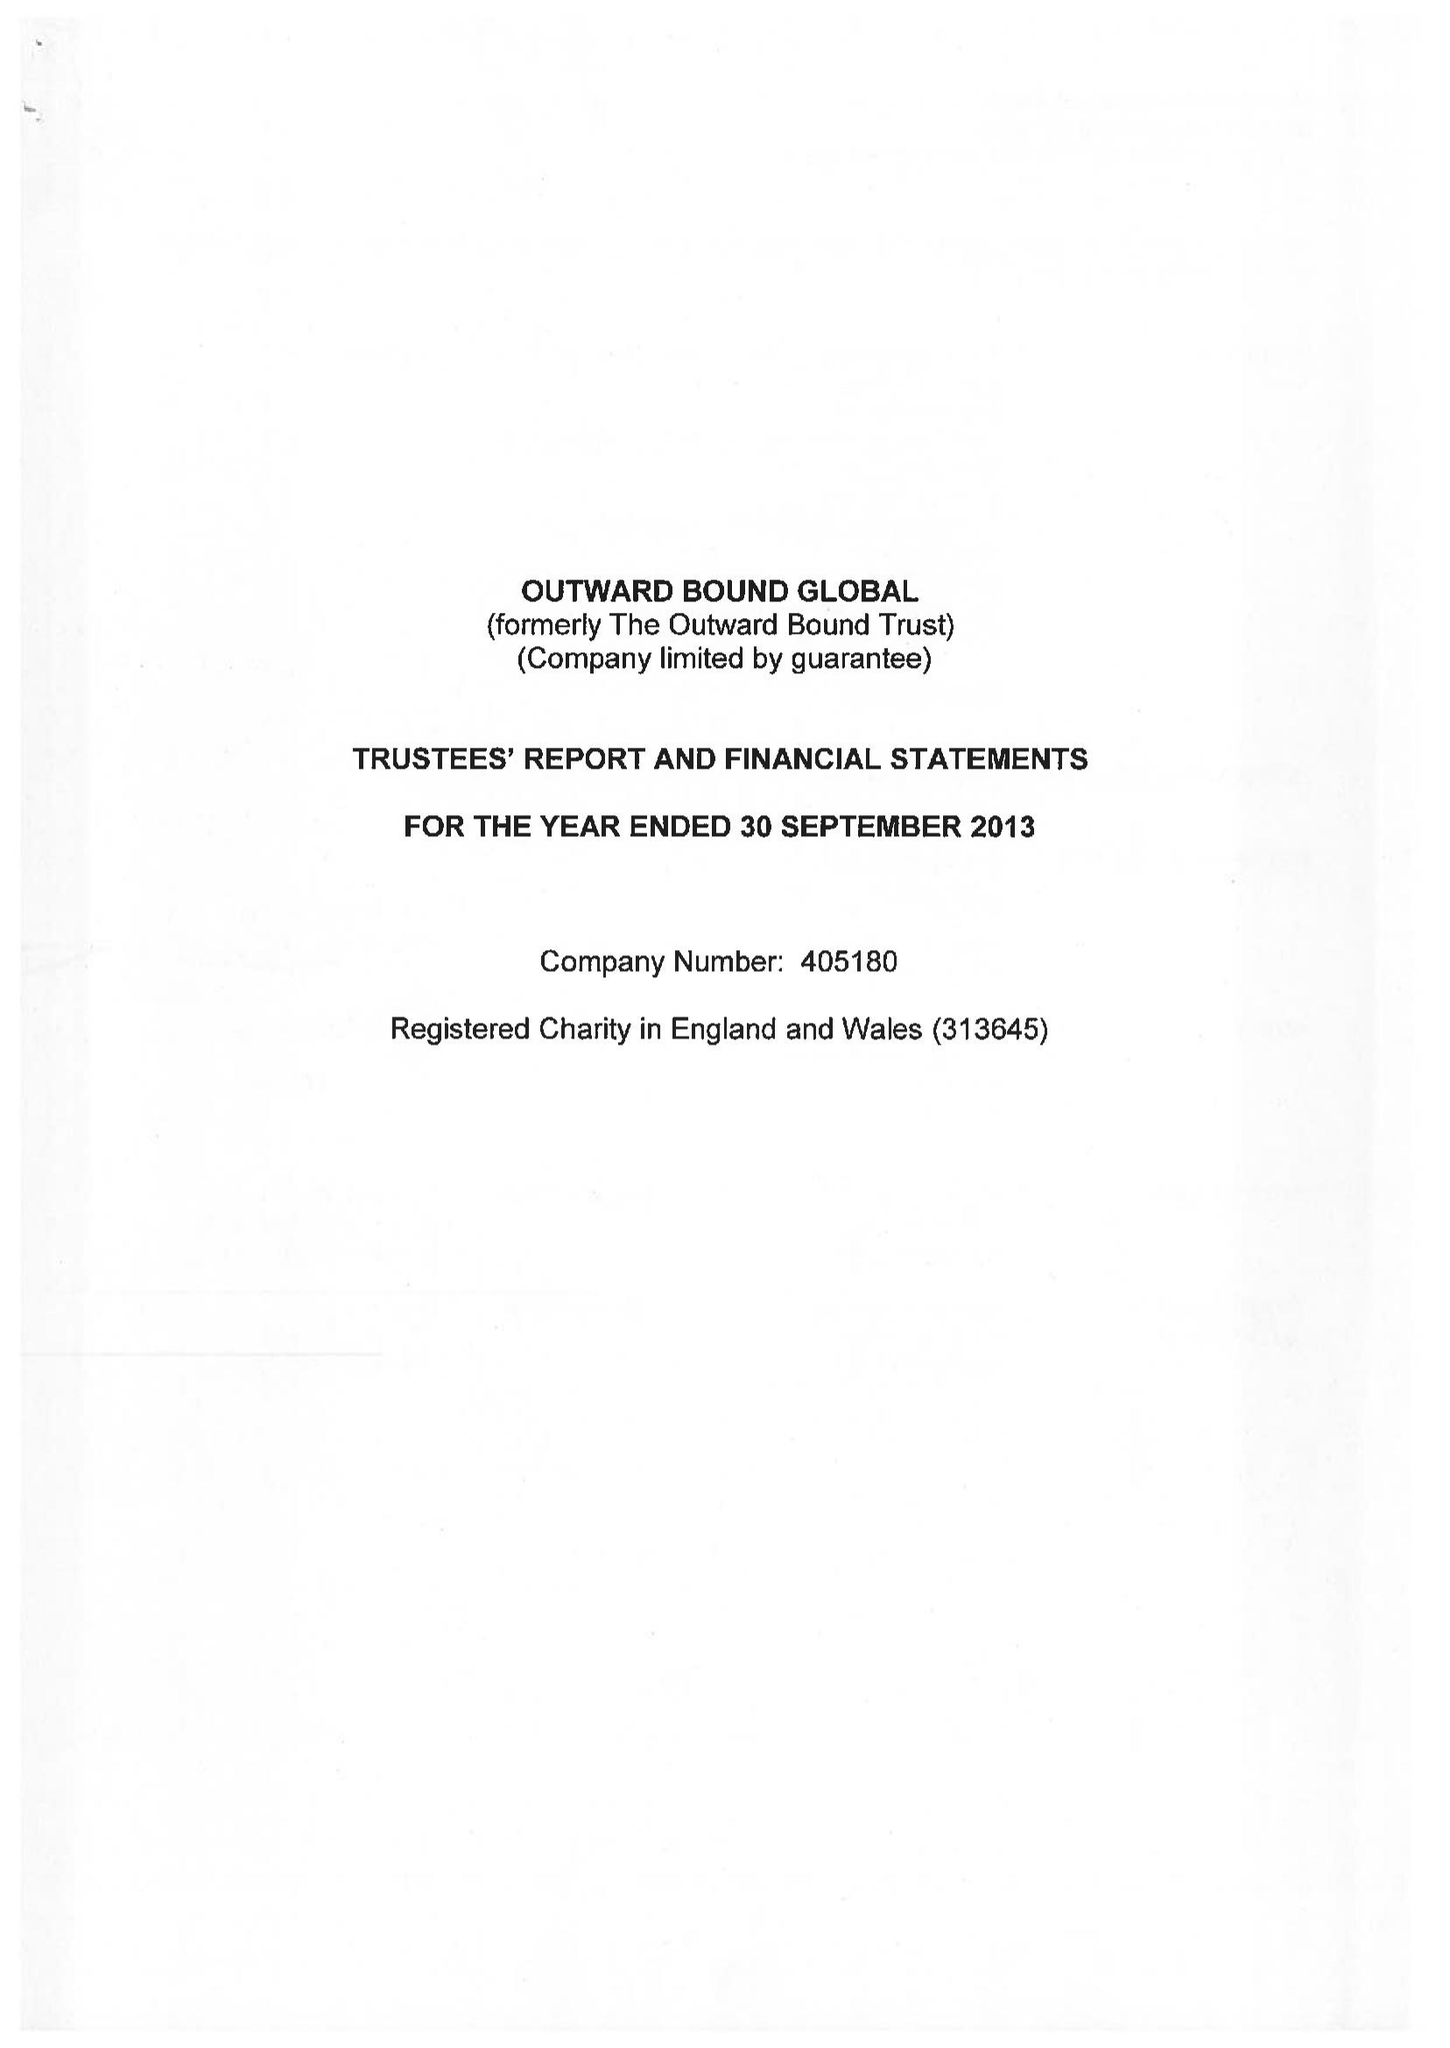What is the value for the address__street_line?
Answer the question using a single word or phrase. None 